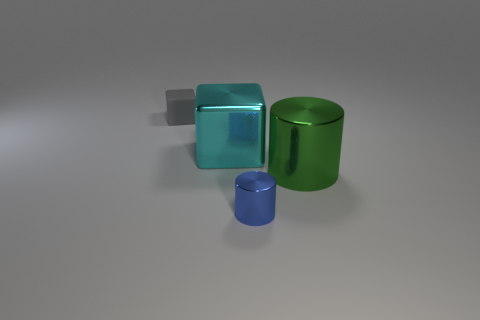Add 4 tiny shiny cylinders. How many objects exist? 8 Subtract all small things. Subtract all big green metallic things. How many objects are left? 1 Add 2 big cyan metallic cubes. How many big cyan metallic cubes are left? 3 Add 1 small blue cylinders. How many small blue cylinders exist? 2 Subtract 1 cyan cubes. How many objects are left? 3 